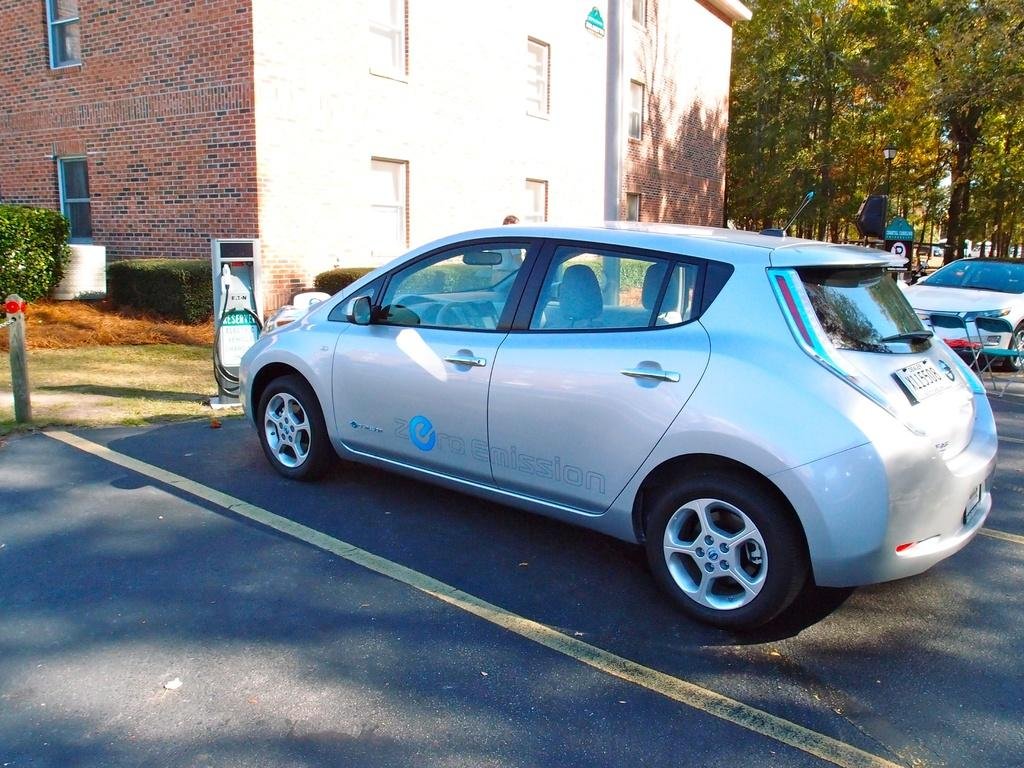What type of vehicles can be seen in the image? There are cars in the image. What type of furniture is present in the image? There are chairs in the image. What is used for dispensing fuel in the image? There is a fuel dispenser in the image. What type of signage is present in the image? There are boards in the image. What type of vertical structures are present in the image? There are poles in the image. What type of vegetation is present in the image? There are plants and grass in the image. What type of natural elements can be seen in the background of the image? There are trees in the background of the image. What type of man-made structure can be seen in the background of the image? There is a building in the background of the image. Where is the hydrant located in the image? There is no hydrant present in the image. What type of wood is used to make the chairs in the image? The chairs in the image are not made of wood, and there is no wood present in the image. How many times does the person kick the ball in the image? There is no person or ball present in the image. 